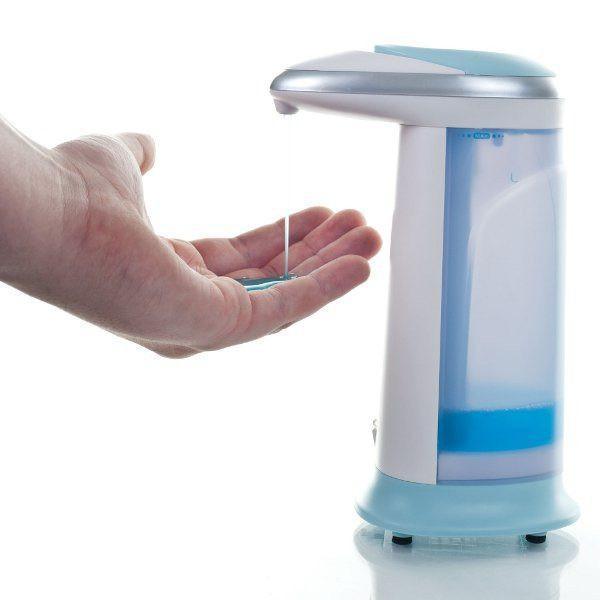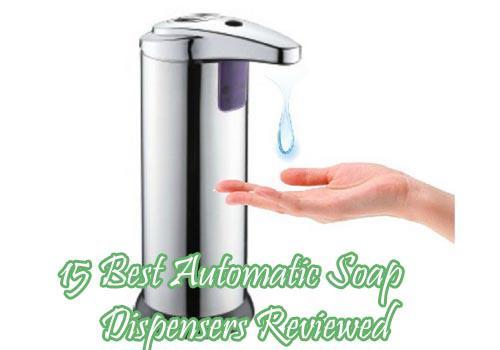The first image is the image on the left, the second image is the image on the right. For the images displayed, is the sentence "One image has no hands." factually correct? Answer yes or no. No. The first image is the image on the left, the second image is the image on the right. Evaluate the accuracy of this statement regarding the images: "There is a hand in the image on the right". Is it true? Answer yes or no. Yes. 